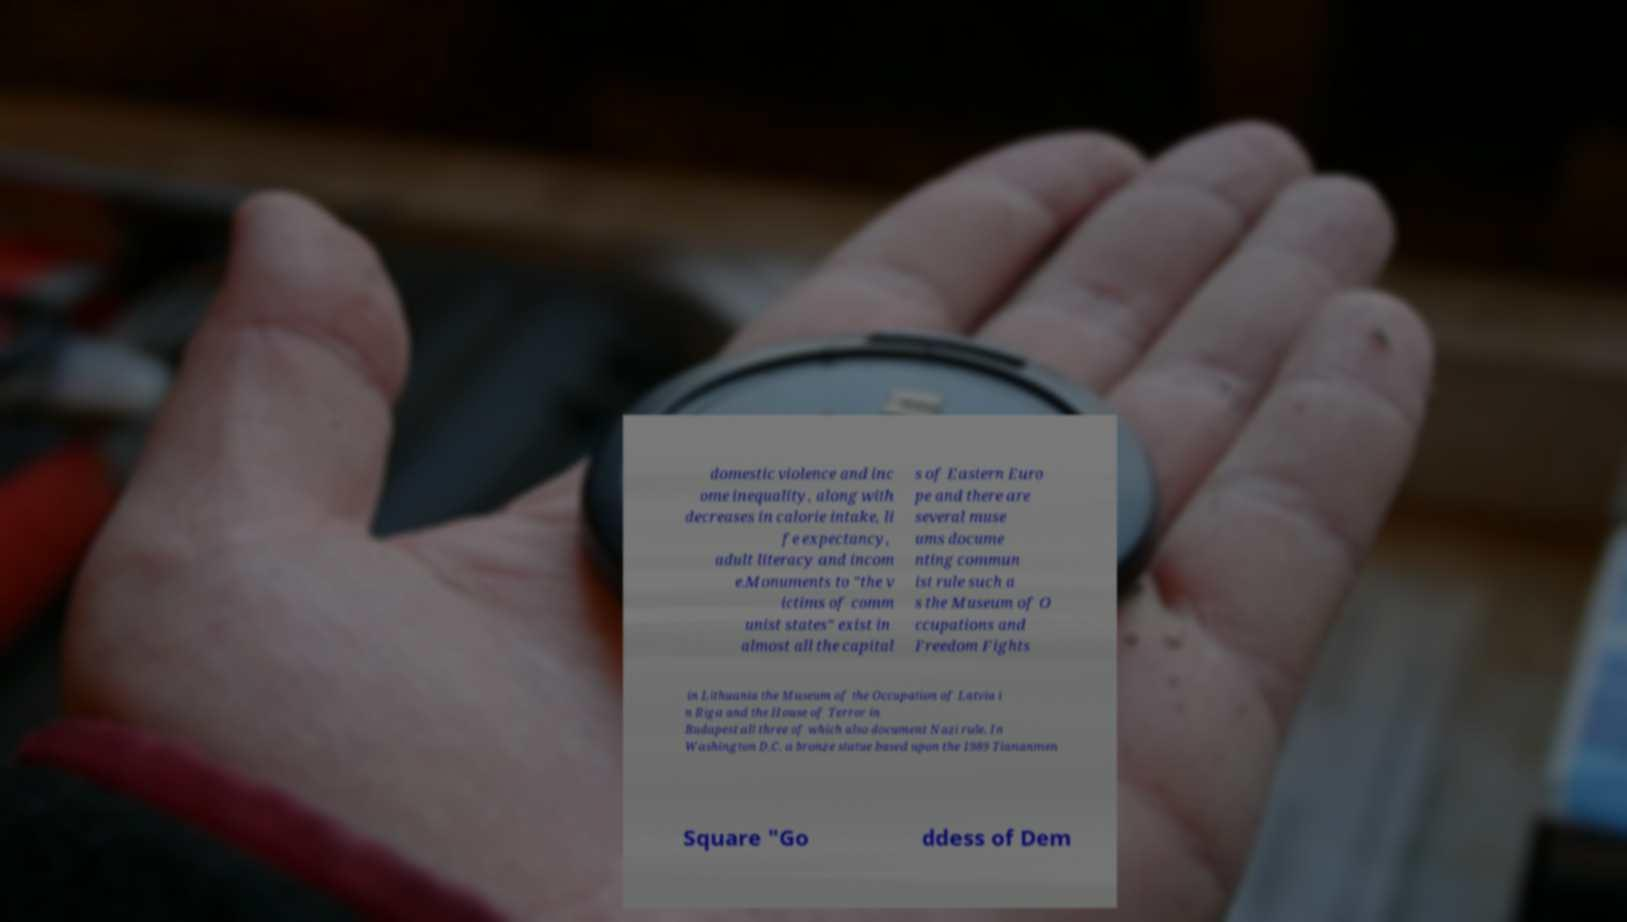For documentation purposes, I need the text within this image transcribed. Could you provide that? domestic violence and inc ome inequality, along with decreases in calorie intake, li fe expectancy, adult literacy and incom e.Monuments to "the v ictims of comm unist states" exist in almost all the capital s of Eastern Euro pe and there are several muse ums docume nting commun ist rule such a s the Museum of O ccupations and Freedom Fights in Lithuania the Museum of the Occupation of Latvia i n Riga and the House of Terror in Budapest all three of which also document Nazi rule. In Washington D.C. a bronze statue based upon the 1989 Tiananmen Square "Go ddess of Dem 